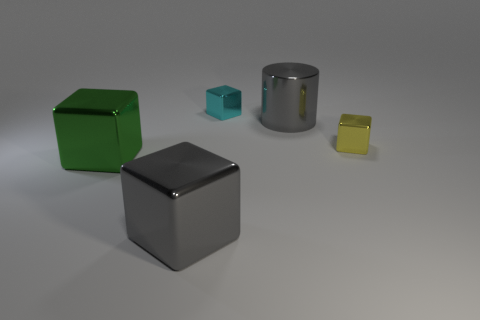Is the number of gray cubes behind the small cyan object greater than the number of tiny yellow cubes that are in front of the green shiny object?
Your answer should be compact. No. The object that is the same color as the large metallic cylinder is what size?
Offer a very short reply. Large. What number of other objects are the same size as the cyan thing?
Your answer should be compact. 1. Are the small cube that is left of the gray shiny cylinder and the yellow thing made of the same material?
Your answer should be very brief. Yes. What number of other objects are the same color as the big cylinder?
Keep it short and to the point. 1. What number of other objects are there of the same shape as the cyan object?
Provide a succinct answer. 3. There is a gray metal object in front of the green metallic block; is it the same shape as the gray thing that is behind the big gray metallic cube?
Offer a terse response. No. Is the number of gray shiny cylinders behind the large metallic cylinder the same as the number of gray blocks that are behind the big green metallic object?
Your answer should be very brief. Yes. There is a gray thing that is behind the tiny metallic block that is to the right of the cube that is behind the yellow metal block; what is its shape?
Make the answer very short. Cylinder. The large gray thing that is in front of the big metallic cylinder has what shape?
Make the answer very short. Cube. 